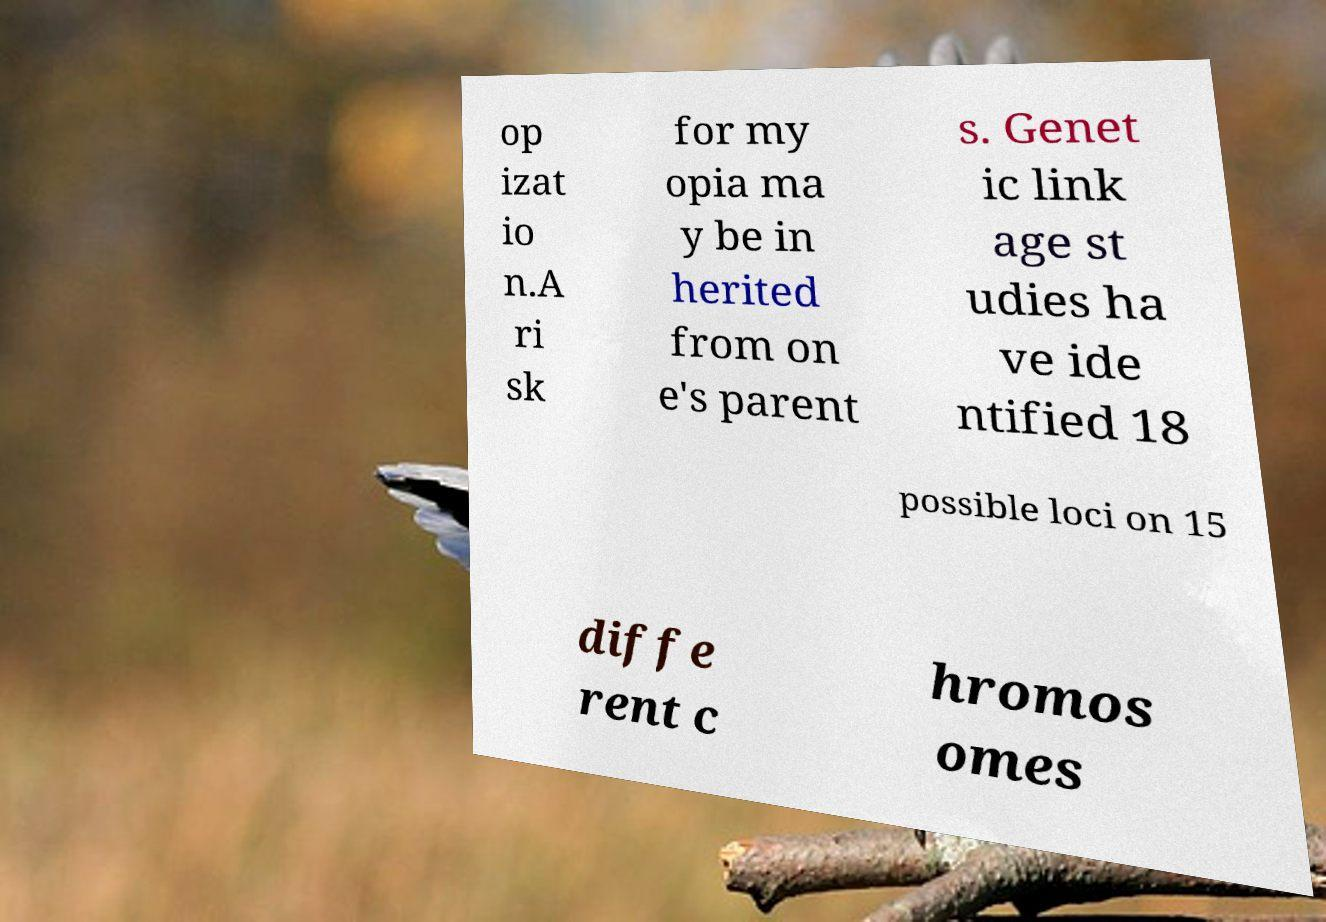There's text embedded in this image that I need extracted. Can you transcribe it verbatim? op izat io n.A ri sk for my opia ma y be in herited from on e's parent s. Genet ic link age st udies ha ve ide ntified 18 possible loci on 15 diffe rent c hromos omes 